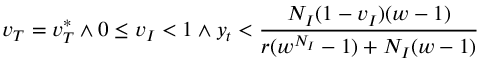Convert formula to latex. <formula><loc_0><loc_0><loc_500><loc_500>v _ { T } = v _ { T } ^ { * } \land 0 \leq v _ { I } < 1 \land y _ { t } < \frac { N _ { I } ( 1 - v _ { I } ) ( w - 1 ) } { r ( w ^ { N _ { I } } - 1 ) + N _ { I } ( w - 1 ) }</formula> 